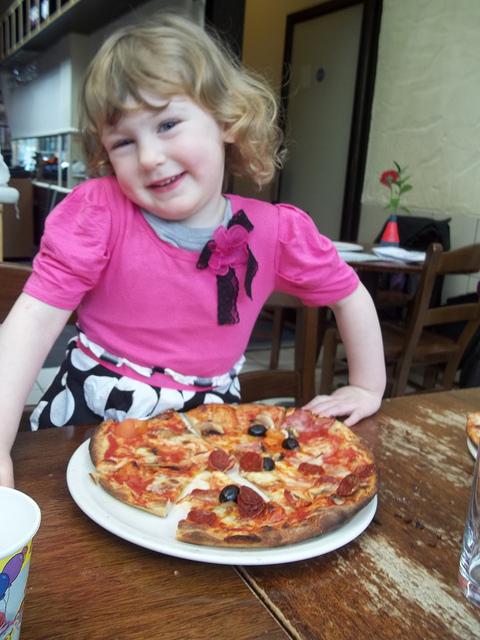How many pepperonis are on the pizza?
Concise answer only. 6. How many pizza?
Give a very brief answer. 1. What is the little girl doing?
Write a very short answer. Smiling. What color is the ribbon below the flower?
Concise answer only. Black. What type of pizza is on the table?
Concise answer only. Pepperoni and olive. What is the girl eating?
Concise answer only. Pizza. Is this ice cream?
Give a very brief answer. No. What shape are the pizzas?
Quick response, please. Round. What are the shapes on the girls skirt?
Give a very brief answer. Circles. What holiday might this pizza be for?
Answer briefly. Birthday. What was the pizza served on?
Quick response, please. Plate. 